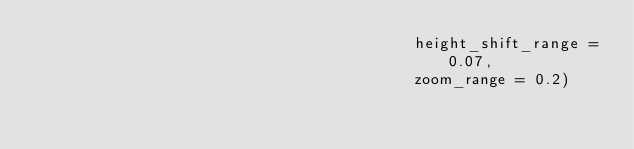Convert code to text. <code><loc_0><loc_0><loc_500><loc_500><_Python_>                                         height_shift_range = 0.07,
                                         zoom_range = 0.2)</code> 